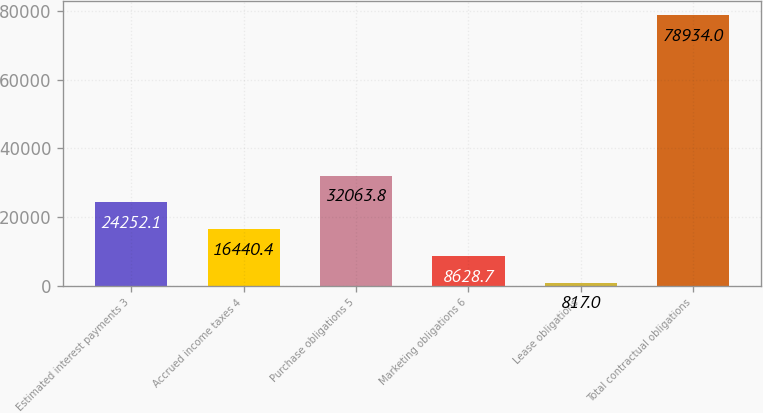Convert chart to OTSL. <chart><loc_0><loc_0><loc_500><loc_500><bar_chart><fcel>Estimated interest payments 3<fcel>Accrued income taxes 4<fcel>Purchase obligations 5<fcel>Marketing obligations 6<fcel>Lease obligations<fcel>Total contractual obligations<nl><fcel>24252.1<fcel>16440.4<fcel>32063.8<fcel>8628.7<fcel>817<fcel>78934<nl></chart> 